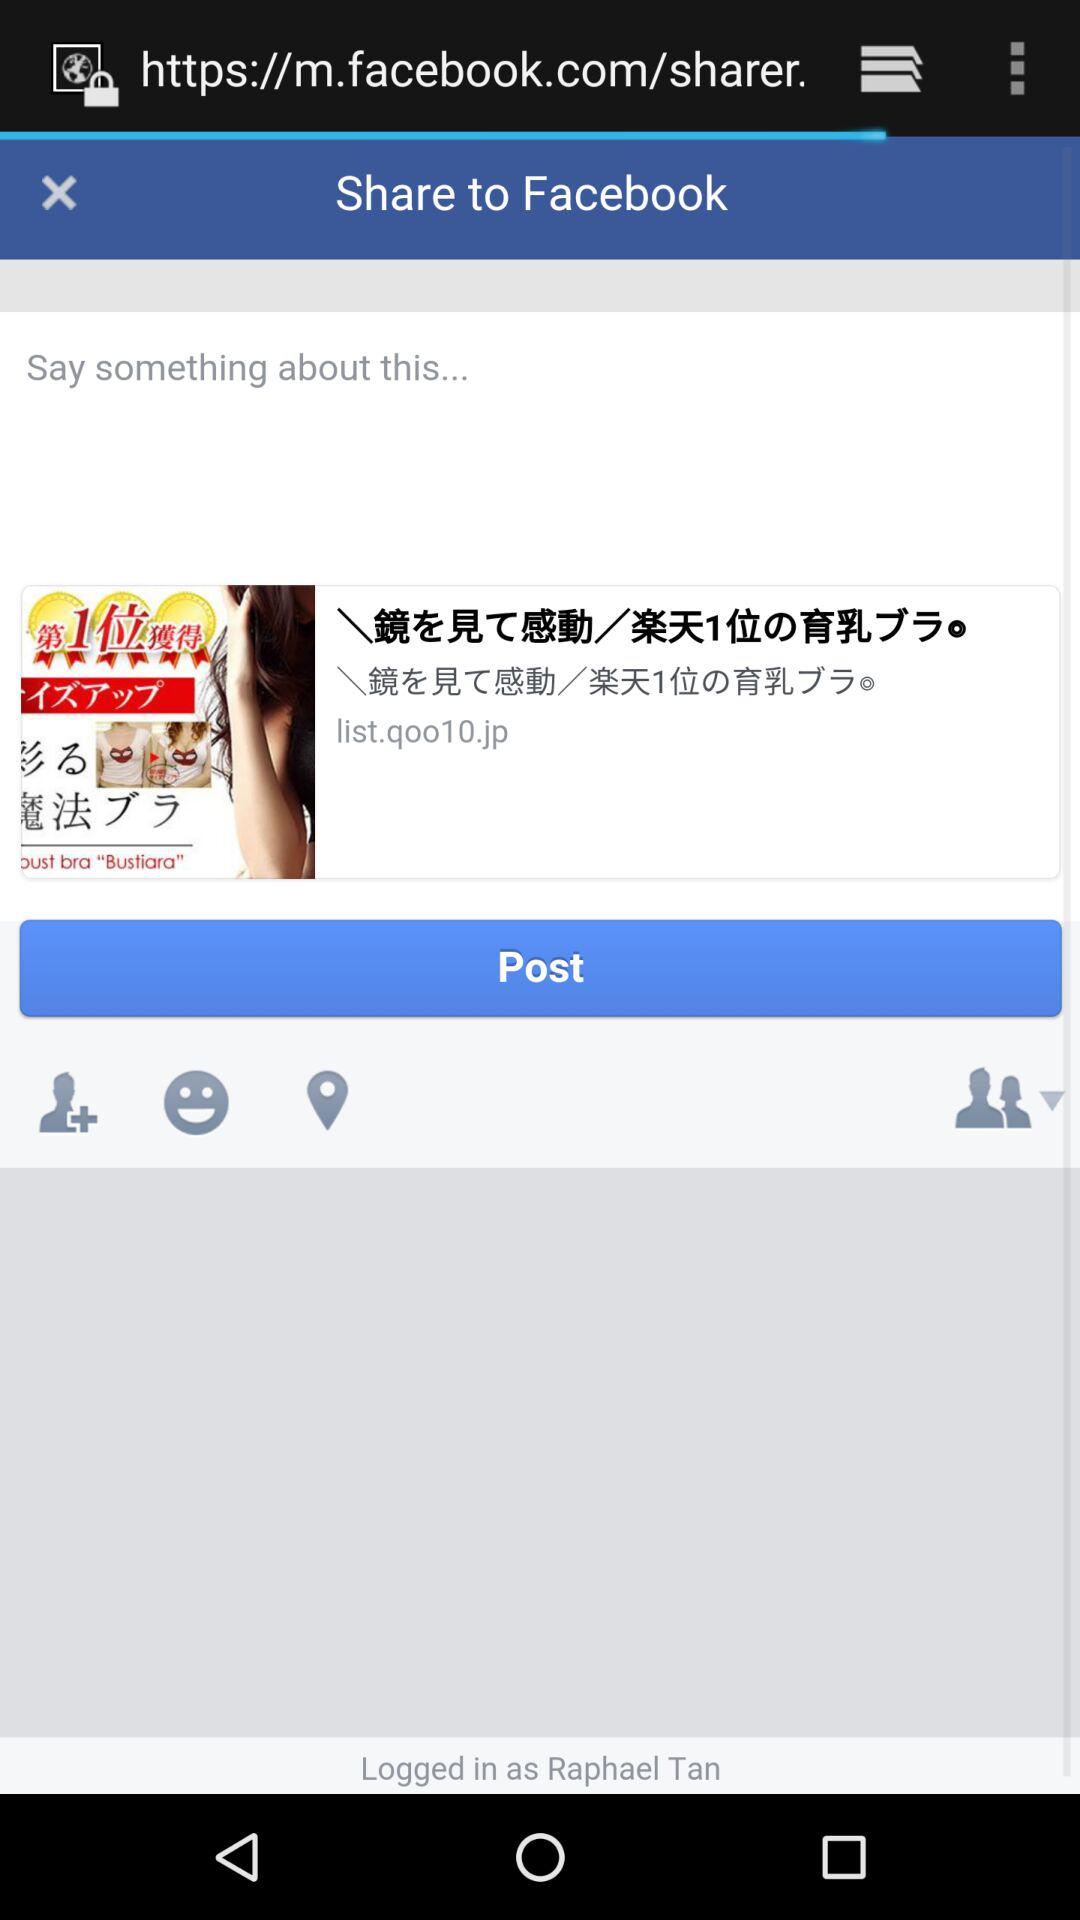What is the user name? The user name is Raphael Tan. 